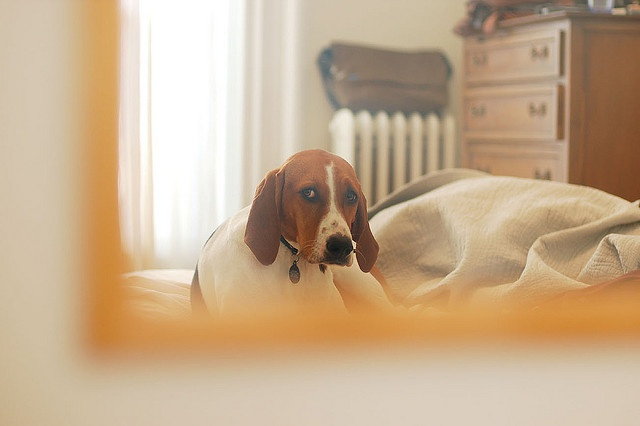Describe the objects in this image and their specific colors. I can see bed in tan tones, dog in tan, gray, and brown tones, and handbag in tan and gray tones in this image. 